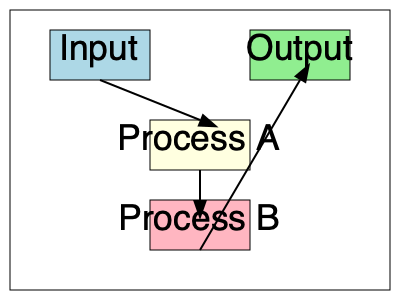In the given system architecture flowchart, what is the correct sequence of data flow? To determine the correct sequence of data flow in this system architecture flowchart, we need to follow these steps:

1. Identify the starting point: The flowchart begins with the "Input" component, represented by the light blue rectangle at the top left.

2. Follow the arrows: Arrows indicate the direction of data flow between components.

3. Trace the path:
   a. Data flows from "Input" to "Process A" (light yellow rectangle).
   b. From "Process A", data moves to "Process B" (light pink rectangle).
   c. Finally, data flows from "Process B" to "Output" (light green rectangle).

4. Conclude the sequence: The correct order of data flow is Input → Process A → Process B → Output.

This sequence represents a linear flow of data through the system, with each component processing the data before passing it to the next stage.
Answer: Input → Process A → Process B → Output 